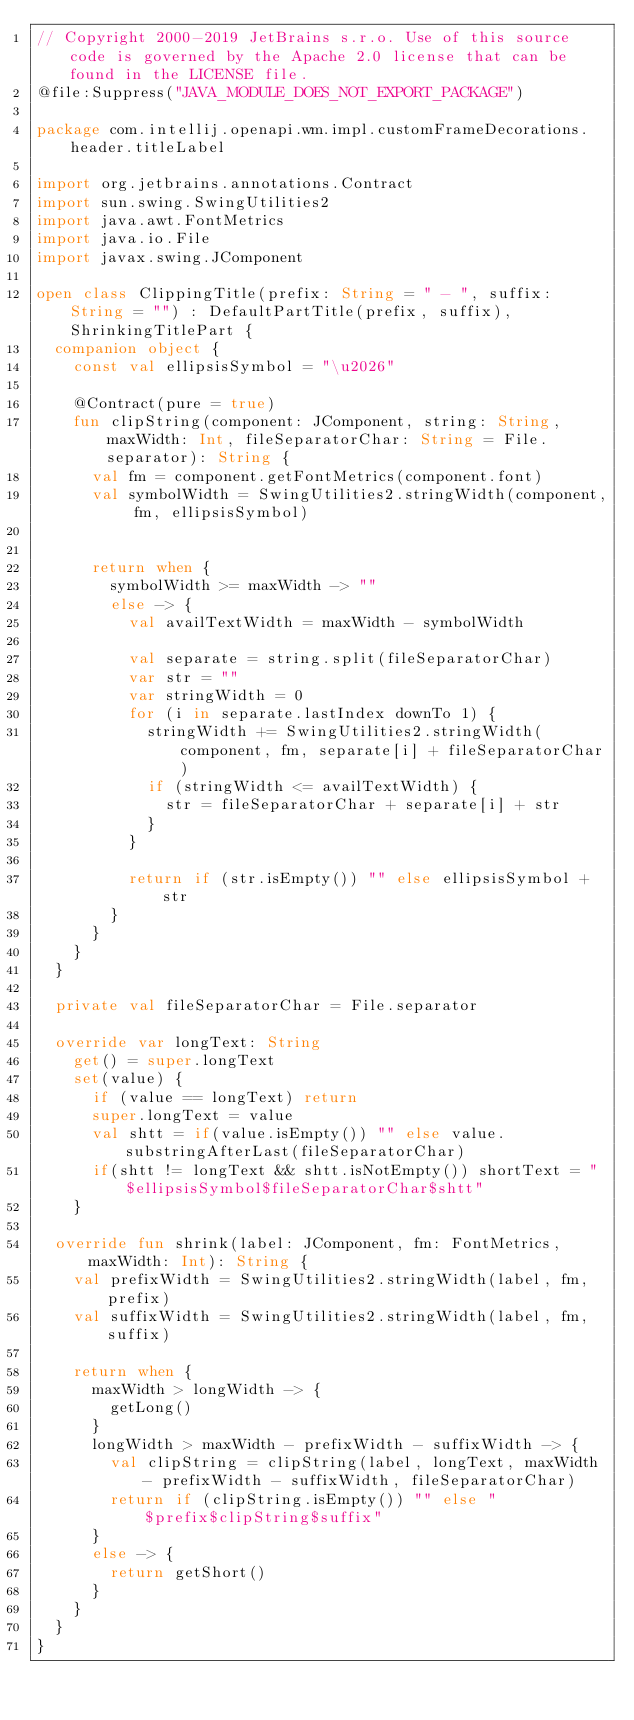Convert code to text. <code><loc_0><loc_0><loc_500><loc_500><_Kotlin_>// Copyright 2000-2019 JetBrains s.r.o. Use of this source code is governed by the Apache 2.0 license that can be found in the LICENSE file.
@file:Suppress("JAVA_MODULE_DOES_NOT_EXPORT_PACKAGE")

package com.intellij.openapi.wm.impl.customFrameDecorations.header.titleLabel

import org.jetbrains.annotations.Contract
import sun.swing.SwingUtilities2
import java.awt.FontMetrics
import java.io.File
import javax.swing.JComponent

open class ClippingTitle(prefix: String = " - ", suffix: String = "") : DefaultPartTitle(prefix, suffix), ShrinkingTitlePart {
  companion object {
    const val ellipsisSymbol = "\u2026"

    @Contract(pure = true)
    fun clipString(component: JComponent, string: String, maxWidth: Int, fileSeparatorChar: String = File.separator): String {
      val fm = component.getFontMetrics(component.font)
      val symbolWidth = SwingUtilities2.stringWidth(component, fm, ellipsisSymbol)


      return when {
        symbolWidth >= maxWidth -> ""
        else -> {
          val availTextWidth = maxWidth - symbolWidth

          val separate = string.split(fileSeparatorChar)
          var str = ""
          var stringWidth = 0
          for (i in separate.lastIndex downTo 1) {
            stringWidth += SwingUtilities2.stringWidth(component, fm, separate[i] + fileSeparatorChar)
            if (stringWidth <= availTextWidth) {
              str = fileSeparatorChar + separate[i] + str
            }
          }

          return if (str.isEmpty()) "" else ellipsisSymbol + str
        }
      }
    }
  }

  private val fileSeparatorChar = File.separator

  override var longText: String
    get() = super.longText
    set(value) {
      if (value == longText) return
      super.longText = value
      val shtt = if(value.isEmpty()) "" else value.substringAfterLast(fileSeparatorChar)
      if(shtt != longText && shtt.isNotEmpty()) shortText = "$ellipsisSymbol$fileSeparatorChar$shtt"
    }

  override fun shrink(label: JComponent, fm: FontMetrics, maxWidth: Int): String {
    val prefixWidth = SwingUtilities2.stringWidth(label, fm, prefix)
    val suffixWidth = SwingUtilities2.stringWidth(label, fm, suffix)

    return when {
      maxWidth > longWidth -> {
        getLong()
      }
      longWidth > maxWidth - prefixWidth - suffixWidth -> {
        val clipString = clipString(label, longText, maxWidth - prefixWidth - suffixWidth, fileSeparatorChar)
        return if (clipString.isEmpty()) "" else "$prefix$clipString$suffix"
      }
      else -> {
        return getShort()
      }
    }
  }
}</code> 